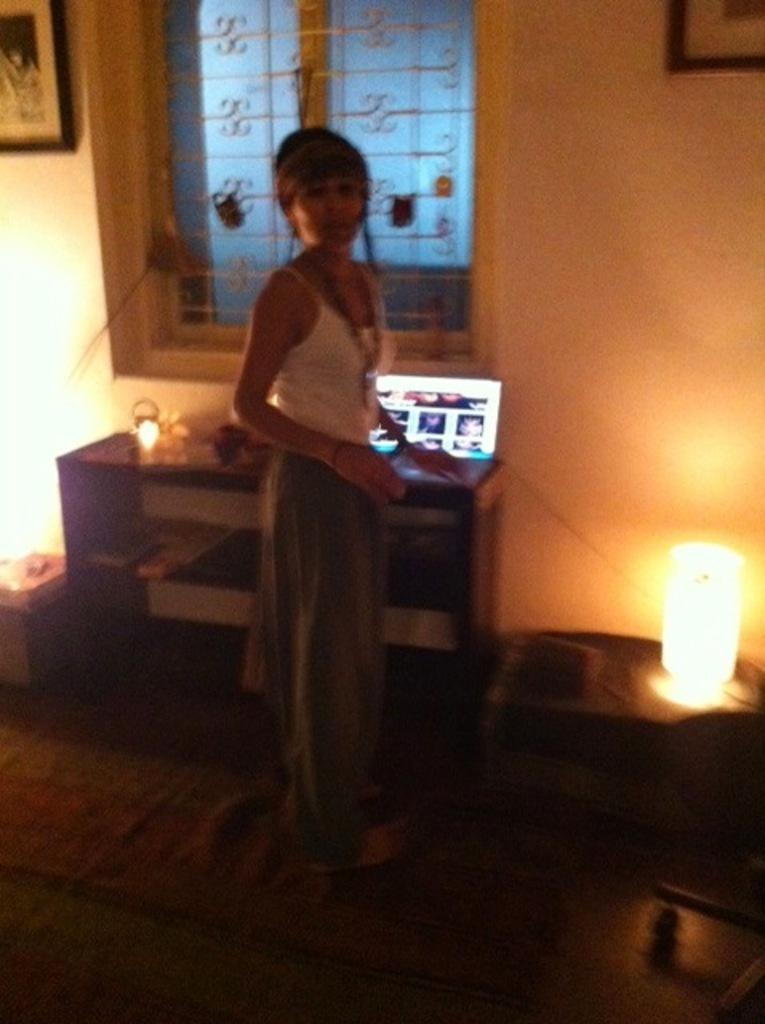What is the main subject of the image? There is a person standing in the image. What objects can be seen in the image besides the person? There is a lamp and a laptop in the image. What can be seen in the background of the image? There is a wall, a window, and a photo frame attached to the wall in the background of the image. What type of cake is being served in the image? There is no cake present in the image. What month is it in the image? The image does not provide any information about the month or time of year. 